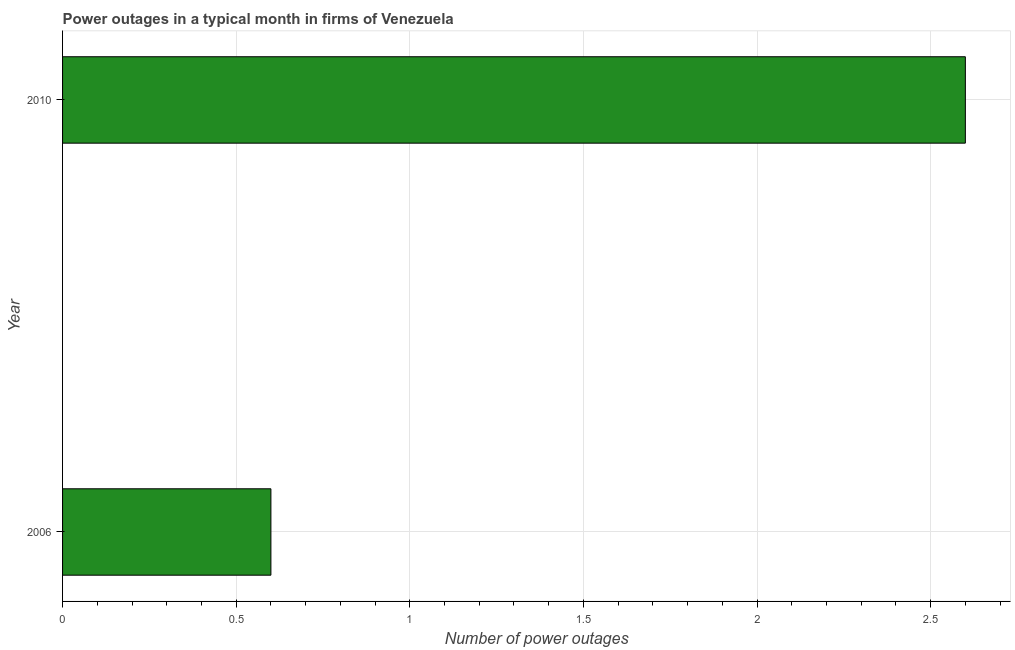Does the graph contain grids?
Keep it short and to the point. Yes. What is the title of the graph?
Offer a very short reply. Power outages in a typical month in firms of Venezuela. What is the label or title of the X-axis?
Your answer should be compact. Number of power outages. What is the label or title of the Y-axis?
Keep it short and to the point. Year. What is the number of power outages in 2006?
Your answer should be compact. 0.6. Across all years, what is the maximum number of power outages?
Offer a terse response. 2.6. Across all years, what is the minimum number of power outages?
Offer a very short reply. 0.6. In which year was the number of power outages maximum?
Your answer should be very brief. 2010. What is the sum of the number of power outages?
Make the answer very short. 3.2. What is the difference between the number of power outages in 2006 and 2010?
Ensure brevity in your answer.  -2. What is the ratio of the number of power outages in 2006 to that in 2010?
Offer a terse response. 0.23. Is the number of power outages in 2006 less than that in 2010?
Your answer should be very brief. Yes. In how many years, is the number of power outages greater than the average number of power outages taken over all years?
Make the answer very short. 1. How many bars are there?
Offer a terse response. 2. Are all the bars in the graph horizontal?
Offer a terse response. Yes. What is the difference between two consecutive major ticks on the X-axis?
Make the answer very short. 0.5. Are the values on the major ticks of X-axis written in scientific E-notation?
Keep it short and to the point. No. What is the Number of power outages of 2006?
Your response must be concise. 0.6. What is the ratio of the Number of power outages in 2006 to that in 2010?
Your answer should be very brief. 0.23. 